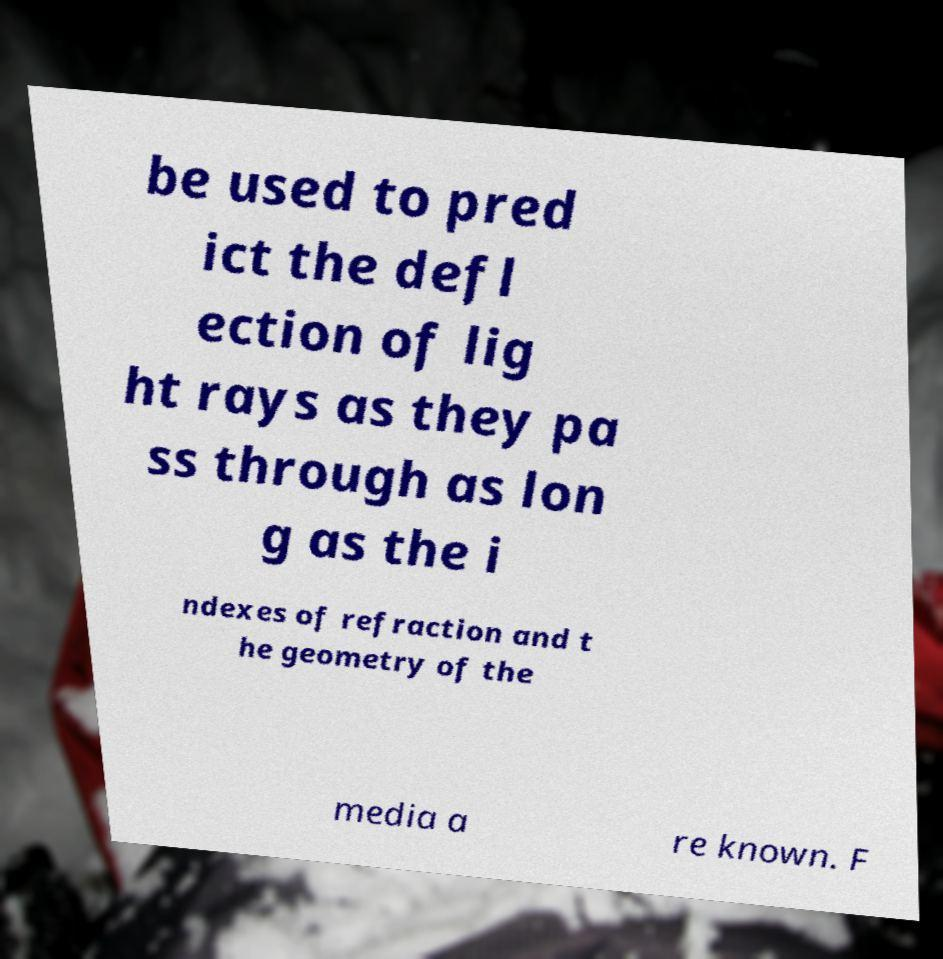There's text embedded in this image that I need extracted. Can you transcribe it verbatim? be used to pred ict the defl ection of lig ht rays as they pa ss through as lon g as the i ndexes of refraction and t he geometry of the media a re known. F 